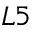Convert formula to latex. <formula><loc_0><loc_0><loc_500><loc_500>L 5</formula> 